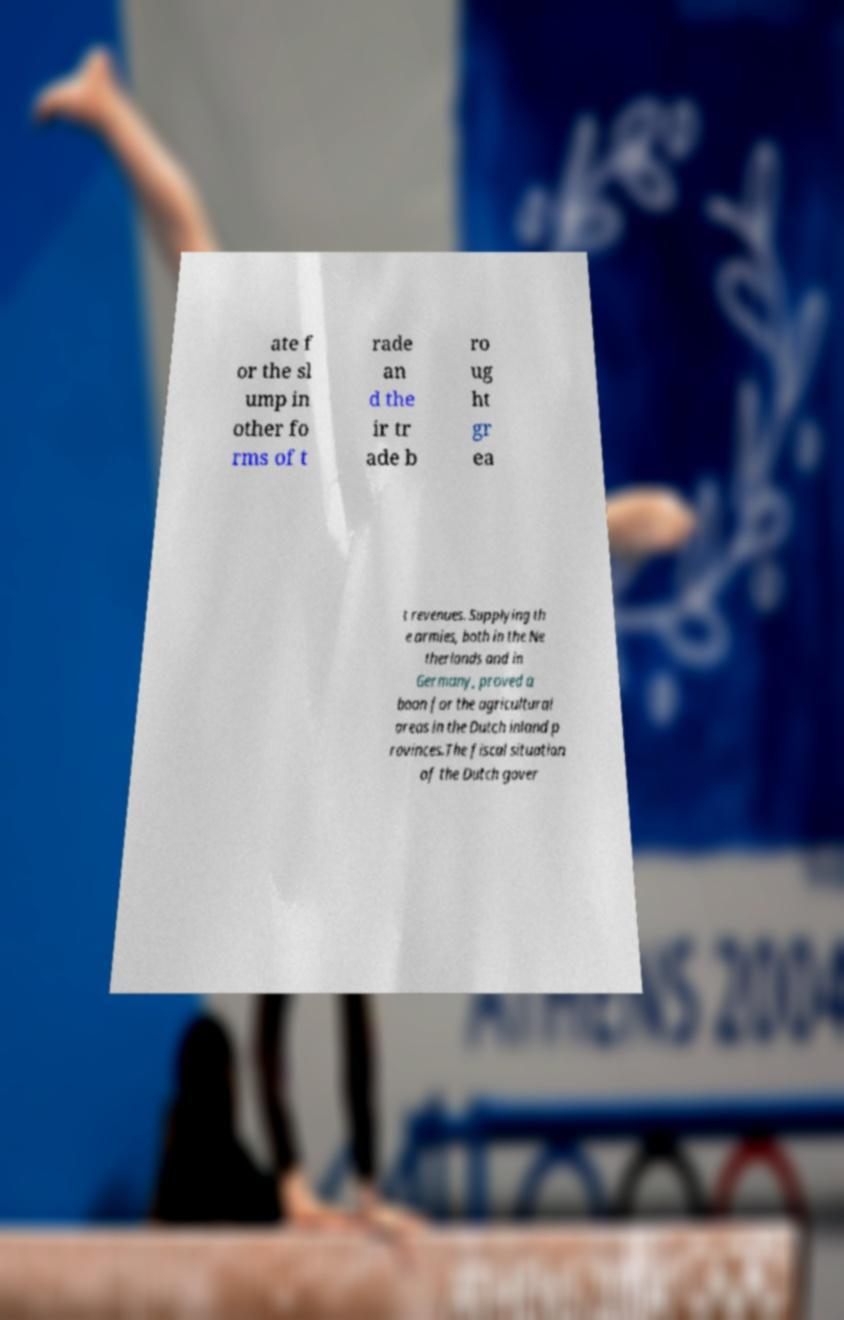Could you assist in decoding the text presented in this image and type it out clearly? ate f or the sl ump in other fo rms of t rade an d the ir tr ade b ro ug ht gr ea t revenues. Supplying th e armies, both in the Ne therlands and in Germany, proved a boon for the agricultural areas in the Dutch inland p rovinces.The fiscal situation of the Dutch gover 